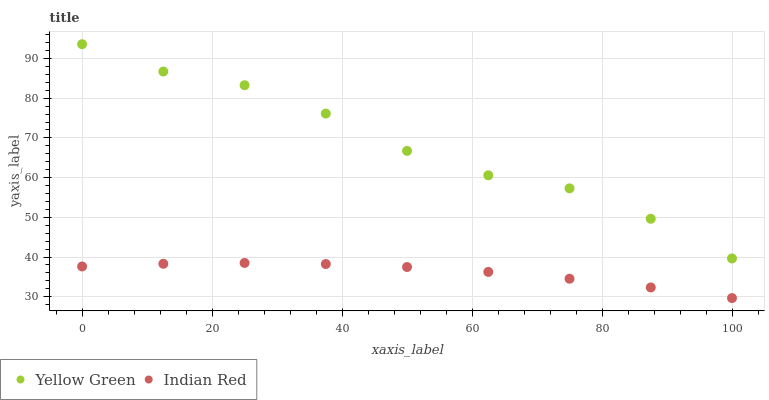Does Indian Red have the minimum area under the curve?
Answer yes or no. Yes. Does Yellow Green have the maximum area under the curve?
Answer yes or no. Yes. Does Indian Red have the maximum area under the curve?
Answer yes or no. No. Is Indian Red the smoothest?
Answer yes or no. Yes. Is Yellow Green the roughest?
Answer yes or no. Yes. Is Indian Red the roughest?
Answer yes or no. No. Does Indian Red have the lowest value?
Answer yes or no. Yes. Does Yellow Green have the highest value?
Answer yes or no. Yes. Does Indian Red have the highest value?
Answer yes or no. No. Is Indian Red less than Yellow Green?
Answer yes or no. Yes. Is Yellow Green greater than Indian Red?
Answer yes or no. Yes. Does Indian Red intersect Yellow Green?
Answer yes or no. No. 